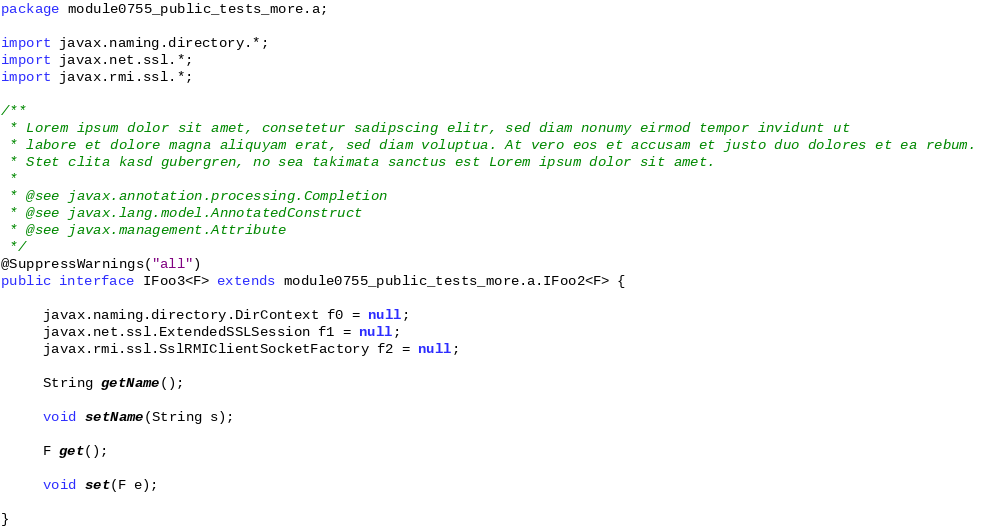<code> <loc_0><loc_0><loc_500><loc_500><_Java_>package module0755_public_tests_more.a;

import javax.naming.directory.*;
import javax.net.ssl.*;
import javax.rmi.ssl.*;

/**
 * Lorem ipsum dolor sit amet, consetetur sadipscing elitr, sed diam nonumy eirmod tempor invidunt ut 
 * labore et dolore magna aliquyam erat, sed diam voluptua. At vero eos et accusam et justo duo dolores et ea rebum. 
 * Stet clita kasd gubergren, no sea takimata sanctus est Lorem ipsum dolor sit amet. 
 *
 * @see javax.annotation.processing.Completion
 * @see javax.lang.model.AnnotatedConstruct
 * @see javax.management.Attribute
 */
@SuppressWarnings("all")
public interface IFoo3<F> extends module0755_public_tests_more.a.IFoo2<F> {

	 javax.naming.directory.DirContext f0 = null;
	 javax.net.ssl.ExtendedSSLSession f1 = null;
	 javax.rmi.ssl.SslRMIClientSocketFactory f2 = null;

	 String getName();

	 void setName(String s);

	 F get();

	 void set(F e);

}
</code> 